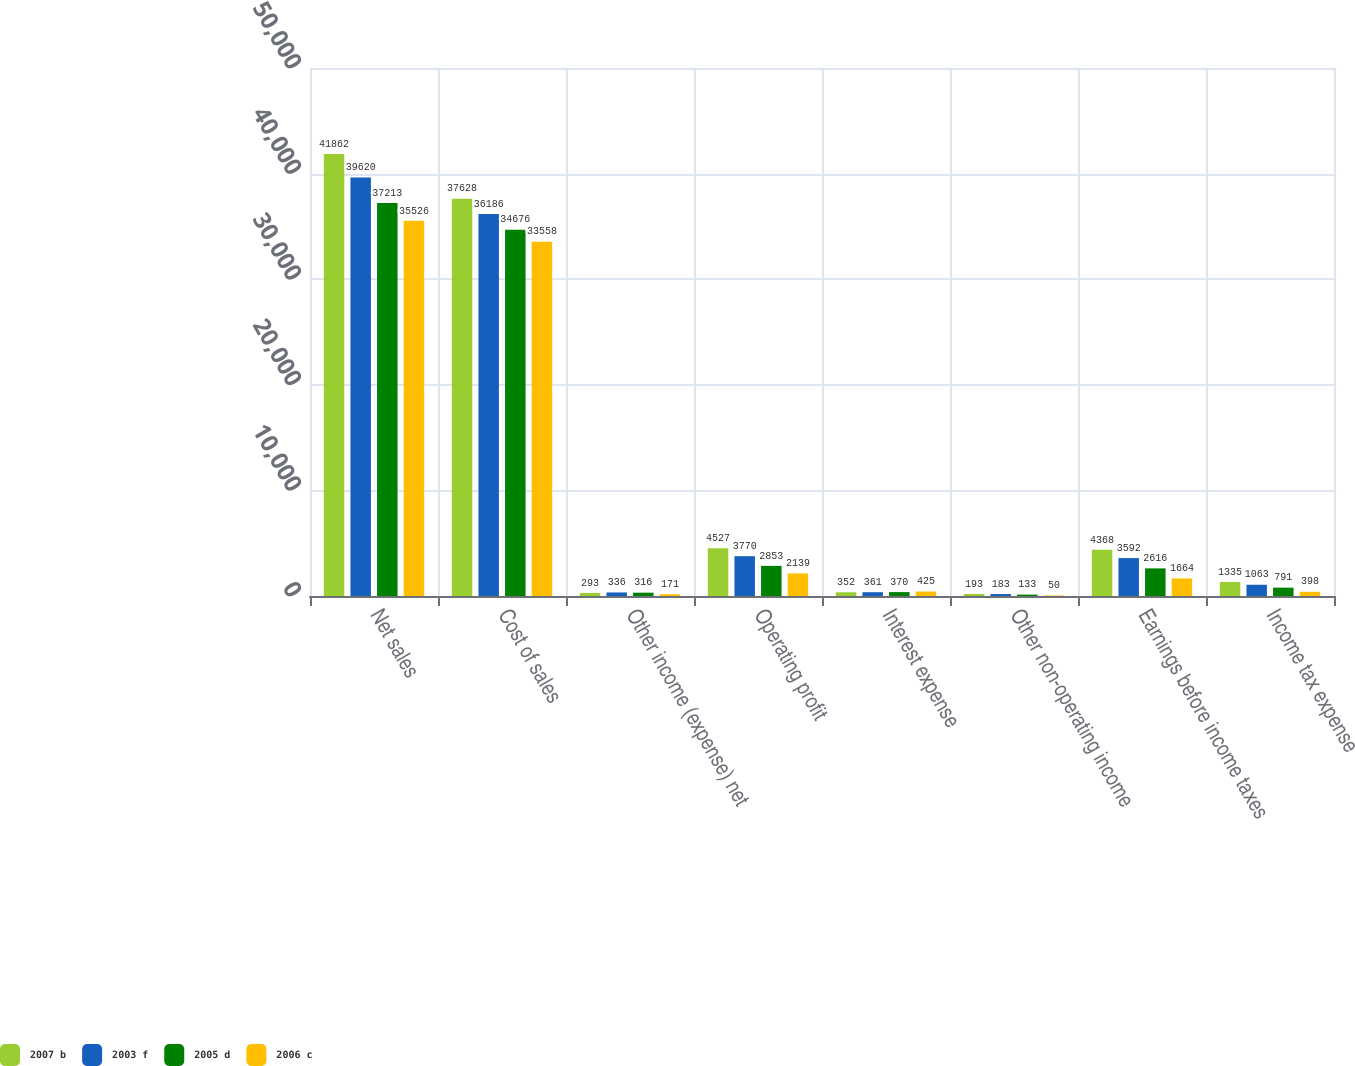Convert chart to OTSL. <chart><loc_0><loc_0><loc_500><loc_500><stacked_bar_chart><ecel><fcel>Net sales<fcel>Cost of sales<fcel>Other income (expense) net<fcel>Operating profit<fcel>Interest expense<fcel>Other non-operating income<fcel>Earnings before income taxes<fcel>Income tax expense<nl><fcel>2007 b<fcel>41862<fcel>37628<fcel>293<fcel>4527<fcel>352<fcel>193<fcel>4368<fcel>1335<nl><fcel>2003 f<fcel>39620<fcel>36186<fcel>336<fcel>3770<fcel>361<fcel>183<fcel>3592<fcel>1063<nl><fcel>2005 d<fcel>37213<fcel>34676<fcel>316<fcel>2853<fcel>370<fcel>133<fcel>2616<fcel>791<nl><fcel>2006 c<fcel>35526<fcel>33558<fcel>171<fcel>2139<fcel>425<fcel>50<fcel>1664<fcel>398<nl></chart> 